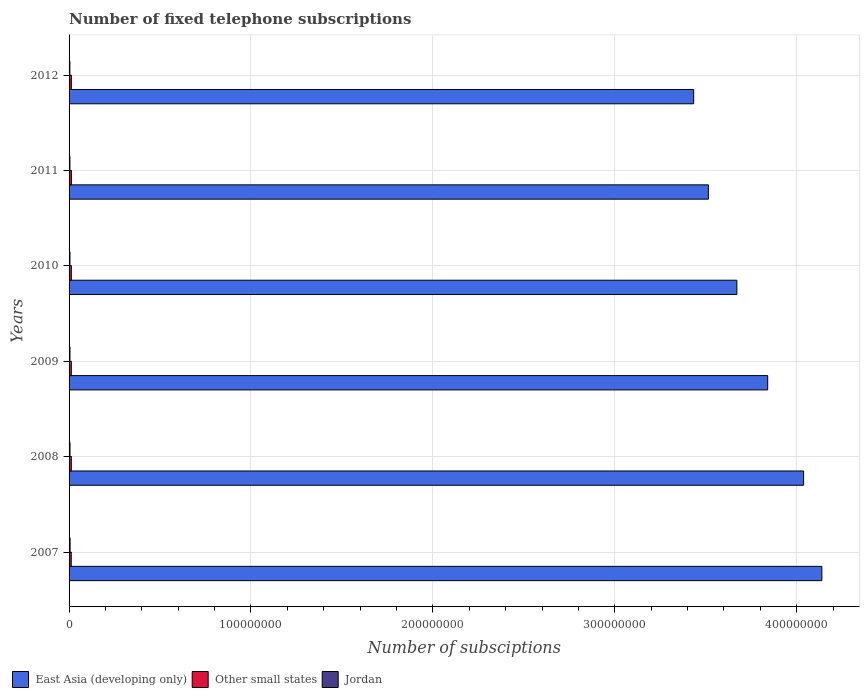How many groups of bars are there?
Provide a succinct answer. 6. Are the number of bars on each tick of the Y-axis equal?
Offer a terse response. Yes. What is the label of the 3rd group of bars from the top?
Keep it short and to the point. 2010. What is the number of fixed telephone subscriptions in Jordan in 2007?
Keep it short and to the point. 5.59e+05. Across all years, what is the maximum number of fixed telephone subscriptions in Other small states?
Provide a short and direct response. 1.27e+06. Across all years, what is the minimum number of fixed telephone subscriptions in East Asia (developing only)?
Your answer should be compact. 3.43e+08. In which year was the number of fixed telephone subscriptions in Jordan maximum?
Make the answer very short. 2007. What is the total number of fixed telephone subscriptions in Jordan in the graph?
Provide a short and direct response. 2.96e+06. What is the difference between the number of fixed telephone subscriptions in Jordan in 2007 and that in 2012?
Offer a terse response. 1.25e+05. What is the difference between the number of fixed telephone subscriptions in Other small states in 2009 and the number of fixed telephone subscriptions in East Asia (developing only) in 2012?
Give a very brief answer. -3.42e+08. What is the average number of fixed telephone subscriptions in Other small states per year?
Your answer should be very brief. 1.24e+06. In the year 2012, what is the difference between the number of fixed telephone subscriptions in Jordan and number of fixed telephone subscriptions in Other small states?
Your answer should be very brief. -8.16e+05. What is the ratio of the number of fixed telephone subscriptions in East Asia (developing only) in 2009 to that in 2010?
Your answer should be compact. 1.05. Is the difference between the number of fixed telephone subscriptions in Jordan in 2007 and 2008 greater than the difference between the number of fixed telephone subscriptions in Other small states in 2007 and 2008?
Offer a terse response. Yes. What is the difference between the highest and the second highest number of fixed telephone subscriptions in Other small states?
Your response must be concise. 1.76e+04. What is the difference between the highest and the lowest number of fixed telephone subscriptions in Other small states?
Offer a very short reply. 6.55e+04. In how many years, is the number of fixed telephone subscriptions in Other small states greater than the average number of fixed telephone subscriptions in Other small states taken over all years?
Provide a succinct answer. 3. Is the sum of the number of fixed telephone subscriptions in Jordan in 2007 and 2011 greater than the maximum number of fixed telephone subscriptions in Other small states across all years?
Provide a succinct answer. No. What does the 2nd bar from the top in 2011 represents?
Give a very brief answer. Other small states. What does the 1st bar from the bottom in 2007 represents?
Your answer should be very brief. East Asia (developing only). Is it the case that in every year, the sum of the number of fixed telephone subscriptions in East Asia (developing only) and number of fixed telephone subscriptions in Jordan is greater than the number of fixed telephone subscriptions in Other small states?
Ensure brevity in your answer.  Yes. Are the values on the major ticks of X-axis written in scientific E-notation?
Your answer should be compact. No. Does the graph contain any zero values?
Keep it short and to the point. No. Does the graph contain grids?
Offer a very short reply. Yes. How are the legend labels stacked?
Ensure brevity in your answer.  Horizontal. What is the title of the graph?
Offer a very short reply. Number of fixed telephone subscriptions. Does "Greenland" appear as one of the legend labels in the graph?
Offer a terse response. No. What is the label or title of the X-axis?
Provide a short and direct response. Number of subsciptions. What is the label or title of the Y-axis?
Provide a succinct answer. Years. What is the Number of subsciptions in East Asia (developing only) in 2007?
Ensure brevity in your answer.  4.14e+08. What is the Number of subsciptions of Other small states in 2007?
Provide a short and direct response. 1.20e+06. What is the Number of subsciptions of Jordan in 2007?
Offer a terse response. 5.59e+05. What is the Number of subsciptions in East Asia (developing only) in 2008?
Give a very brief answer. 4.04e+08. What is the Number of subsciptions in Other small states in 2008?
Ensure brevity in your answer.  1.23e+06. What is the Number of subsciptions of Jordan in 2008?
Your answer should be compact. 5.19e+05. What is the Number of subsciptions of East Asia (developing only) in 2009?
Ensure brevity in your answer.  3.84e+08. What is the Number of subsciptions of Other small states in 2009?
Ensure brevity in your answer.  1.23e+06. What is the Number of subsciptions in Jordan in 2009?
Give a very brief answer. 5.01e+05. What is the Number of subsciptions of East Asia (developing only) in 2010?
Your answer should be very brief. 3.67e+08. What is the Number of subsciptions of Other small states in 2010?
Make the answer very short. 1.24e+06. What is the Number of subsciptions of Jordan in 2010?
Offer a very short reply. 4.86e+05. What is the Number of subsciptions of East Asia (developing only) in 2011?
Your answer should be very brief. 3.52e+08. What is the Number of subsciptions of Other small states in 2011?
Your response must be concise. 1.27e+06. What is the Number of subsciptions in Jordan in 2011?
Your answer should be compact. 4.65e+05. What is the Number of subsciptions of East Asia (developing only) in 2012?
Provide a short and direct response. 3.43e+08. What is the Number of subsciptions in Other small states in 2012?
Your answer should be very brief. 1.25e+06. What is the Number of subsciptions of Jordan in 2012?
Make the answer very short. 4.34e+05. Across all years, what is the maximum Number of subsciptions in East Asia (developing only)?
Make the answer very short. 4.14e+08. Across all years, what is the maximum Number of subsciptions in Other small states?
Your response must be concise. 1.27e+06. Across all years, what is the maximum Number of subsciptions of Jordan?
Provide a succinct answer. 5.59e+05. Across all years, what is the minimum Number of subsciptions in East Asia (developing only)?
Your answer should be very brief. 3.43e+08. Across all years, what is the minimum Number of subsciptions in Other small states?
Keep it short and to the point. 1.20e+06. Across all years, what is the minimum Number of subsciptions in Jordan?
Make the answer very short. 4.34e+05. What is the total Number of subsciptions of East Asia (developing only) in the graph?
Give a very brief answer. 2.26e+09. What is the total Number of subsciptions in Other small states in the graph?
Your answer should be compact. 7.42e+06. What is the total Number of subsciptions in Jordan in the graph?
Your response must be concise. 2.96e+06. What is the difference between the Number of subsciptions in East Asia (developing only) in 2007 and that in 2008?
Your response must be concise. 1.00e+07. What is the difference between the Number of subsciptions of Other small states in 2007 and that in 2008?
Make the answer very short. -2.89e+04. What is the difference between the Number of subsciptions of Jordan in 2007 and that in 2008?
Offer a very short reply. 4.00e+04. What is the difference between the Number of subsciptions of East Asia (developing only) in 2007 and that in 2009?
Your answer should be compact. 2.98e+07. What is the difference between the Number of subsciptions of Other small states in 2007 and that in 2009?
Your answer should be very brief. -2.89e+04. What is the difference between the Number of subsciptions in Jordan in 2007 and that in 2009?
Provide a succinct answer. 5.78e+04. What is the difference between the Number of subsciptions in East Asia (developing only) in 2007 and that in 2010?
Offer a very short reply. 4.67e+07. What is the difference between the Number of subsciptions of Other small states in 2007 and that in 2010?
Keep it short and to the point. -3.91e+04. What is the difference between the Number of subsciptions in Jordan in 2007 and that in 2010?
Provide a short and direct response. 7.35e+04. What is the difference between the Number of subsciptions in East Asia (developing only) in 2007 and that in 2011?
Your answer should be compact. 6.24e+07. What is the difference between the Number of subsciptions in Other small states in 2007 and that in 2011?
Your response must be concise. -6.55e+04. What is the difference between the Number of subsciptions in Jordan in 2007 and that in 2011?
Provide a succinct answer. 9.36e+04. What is the difference between the Number of subsciptions of East Asia (developing only) in 2007 and that in 2012?
Provide a short and direct response. 7.05e+07. What is the difference between the Number of subsciptions of Other small states in 2007 and that in 2012?
Give a very brief answer. -4.79e+04. What is the difference between the Number of subsciptions of Jordan in 2007 and that in 2012?
Provide a succinct answer. 1.25e+05. What is the difference between the Number of subsciptions in East Asia (developing only) in 2008 and that in 2009?
Offer a very short reply. 1.97e+07. What is the difference between the Number of subsciptions in Other small states in 2008 and that in 2009?
Your response must be concise. -35. What is the difference between the Number of subsciptions of Jordan in 2008 and that in 2009?
Your answer should be very brief. 1.78e+04. What is the difference between the Number of subsciptions of East Asia (developing only) in 2008 and that in 2010?
Make the answer very short. 3.67e+07. What is the difference between the Number of subsciptions in Other small states in 2008 and that in 2010?
Provide a succinct answer. -1.02e+04. What is the difference between the Number of subsciptions in Jordan in 2008 and that in 2010?
Your answer should be compact. 3.35e+04. What is the difference between the Number of subsciptions of East Asia (developing only) in 2008 and that in 2011?
Your response must be concise. 5.23e+07. What is the difference between the Number of subsciptions of Other small states in 2008 and that in 2011?
Your response must be concise. -3.67e+04. What is the difference between the Number of subsciptions in Jordan in 2008 and that in 2011?
Make the answer very short. 5.36e+04. What is the difference between the Number of subsciptions in East Asia (developing only) in 2008 and that in 2012?
Offer a very short reply. 6.04e+07. What is the difference between the Number of subsciptions of Other small states in 2008 and that in 2012?
Your answer should be very brief. -1.90e+04. What is the difference between the Number of subsciptions in Jordan in 2008 and that in 2012?
Ensure brevity in your answer.  8.46e+04. What is the difference between the Number of subsciptions in East Asia (developing only) in 2009 and that in 2010?
Provide a short and direct response. 1.69e+07. What is the difference between the Number of subsciptions of Other small states in 2009 and that in 2010?
Make the answer very short. -1.02e+04. What is the difference between the Number of subsciptions in Jordan in 2009 and that in 2010?
Keep it short and to the point. 1.57e+04. What is the difference between the Number of subsciptions in East Asia (developing only) in 2009 and that in 2011?
Your answer should be compact. 3.26e+07. What is the difference between the Number of subsciptions of Other small states in 2009 and that in 2011?
Provide a short and direct response. -3.66e+04. What is the difference between the Number of subsciptions in Jordan in 2009 and that in 2011?
Give a very brief answer. 3.58e+04. What is the difference between the Number of subsciptions of East Asia (developing only) in 2009 and that in 2012?
Make the answer very short. 4.07e+07. What is the difference between the Number of subsciptions in Other small states in 2009 and that in 2012?
Offer a very short reply. -1.90e+04. What is the difference between the Number of subsciptions in Jordan in 2009 and that in 2012?
Your response must be concise. 6.68e+04. What is the difference between the Number of subsciptions in East Asia (developing only) in 2010 and that in 2011?
Make the answer very short. 1.56e+07. What is the difference between the Number of subsciptions in Other small states in 2010 and that in 2011?
Offer a terse response. -2.65e+04. What is the difference between the Number of subsciptions of Jordan in 2010 and that in 2011?
Ensure brevity in your answer.  2.01e+04. What is the difference between the Number of subsciptions in East Asia (developing only) in 2010 and that in 2012?
Make the answer very short. 2.38e+07. What is the difference between the Number of subsciptions in Other small states in 2010 and that in 2012?
Give a very brief answer. -8862. What is the difference between the Number of subsciptions in Jordan in 2010 and that in 2012?
Give a very brief answer. 5.11e+04. What is the difference between the Number of subsciptions of East Asia (developing only) in 2011 and that in 2012?
Make the answer very short. 8.12e+06. What is the difference between the Number of subsciptions of Other small states in 2011 and that in 2012?
Offer a terse response. 1.76e+04. What is the difference between the Number of subsciptions of Jordan in 2011 and that in 2012?
Your answer should be very brief. 3.10e+04. What is the difference between the Number of subsciptions in East Asia (developing only) in 2007 and the Number of subsciptions in Other small states in 2008?
Offer a very short reply. 4.13e+08. What is the difference between the Number of subsciptions in East Asia (developing only) in 2007 and the Number of subsciptions in Jordan in 2008?
Your answer should be very brief. 4.13e+08. What is the difference between the Number of subsciptions in Other small states in 2007 and the Number of subsciptions in Jordan in 2008?
Make the answer very short. 6.83e+05. What is the difference between the Number of subsciptions in East Asia (developing only) in 2007 and the Number of subsciptions in Other small states in 2009?
Give a very brief answer. 4.13e+08. What is the difference between the Number of subsciptions in East Asia (developing only) in 2007 and the Number of subsciptions in Jordan in 2009?
Make the answer very short. 4.13e+08. What is the difference between the Number of subsciptions of Other small states in 2007 and the Number of subsciptions of Jordan in 2009?
Your answer should be very brief. 7.01e+05. What is the difference between the Number of subsciptions of East Asia (developing only) in 2007 and the Number of subsciptions of Other small states in 2010?
Offer a terse response. 4.13e+08. What is the difference between the Number of subsciptions in East Asia (developing only) in 2007 and the Number of subsciptions in Jordan in 2010?
Your response must be concise. 4.13e+08. What is the difference between the Number of subsciptions in Other small states in 2007 and the Number of subsciptions in Jordan in 2010?
Make the answer very short. 7.16e+05. What is the difference between the Number of subsciptions of East Asia (developing only) in 2007 and the Number of subsciptions of Other small states in 2011?
Your answer should be very brief. 4.13e+08. What is the difference between the Number of subsciptions of East Asia (developing only) in 2007 and the Number of subsciptions of Jordan in 2011?
Provide a short and direct response. 4.13e+08. What is the difference between the Number of subsciptions of Other small states in 2007 and the Number of subsciptions of Jordan in 2011?
Offer a terse response. 7.37e+05. What is the difference between the Number of subsciptions in East Asia (developing only) in 2007 and the Number of subsciptions in Other small states in 2012?
Give a very brief answer. 4.13e+08. What is the difference between the Number of subsciptions in East Asia (developing only) in 2007 and the Number of subsciptions in Jordan in 2012?
Offer a terse response. 4.13e+08. What is the difference between the Number of subsciptions of Other small states in 2007 and the Number of subsciptions of Jordan in 2012?
Provide a short and direct response. 7.68e+05. What is the difference between the Number of subsciptions in East Asia (developing only) in 2008 and the Number of subsciptions in Other small states in 2009?
Offer a terse response. 4.03e+08. What is the difference between the Number of subsciptions in East Asia (developing only) in 2008 and the Number of subsciptions in Jordan in 2009?
Your answer should be compact. 4.03e+08. What is the difference between the Number of subsciptions of Other small states in 2008 and the Number of subsciptions of Jordan in 2009?
Your answer should be very brief. 7.30e+05. What is the difference between the Number of subsciptions of East Asia (developing only) in 2008 and the Number of subsciptions of Other small states in 2010?
Give a very brief answer. 4.03e+08. What is the difference between the Number of subsciptions of East Asia (developing only) in 2008 and the Number of subsciptions of Jordan in 2010?
Offer a terse response. 4.03e+08. What is the difference between the Number of subsciptions in Other small states in 2008 and the Number of subsciptions in Jordan in 2010?
Your answer should be very brief. 7.45e+05. What is the difference between the Number of subsciptions in East Asia (developing only) in 2008 and the Number of subsciptions in Other small states in 2011?
Give a very brief answer. 4.03e+08. What is the difference between the Number of subsciptions in East Asia (developing only) in 2008 and the Number of subsciptions in Jordan in 2011?
Ensure brevity in your answer.  4.03e+08. What is the difference between the Number of subsciptions in Other small states in 2008 and the Number of subsciptions in Jordan in 2011?
Your response must be concise. 7.66e+05. What is the difference between the Number of subsciptions in East Asia (developing only) in 2008 and the Number of subsciptions in Other small states in 2012?
Your answer should be very brief. 4.03e+08. What is the difference between the Number of subsciptions in East Asia (developing only) in 2008 and the Number of subsciptions in Jordan in 2012?
Provide a short and direct response. 4.03e+08. What is the difference between the Number of subsciptions of Other small states in 2008 and the Number of subsciptions of Jordan in 2012?
Your answer should be very brief. 7.96e+05. What is the difference between the Number of subsciptions of East Asia (developing only) in 2009 and the Number of subsciptions of Other small states in 2010?
Your response must be concise. 3.83e+08. What is the difference between the Number of subsciptions of East Asia (developing only) in 2009 and the Number of subsciptions of Jordan in 2010?
Offer a very short reply. 3.84e+08. What is the difference between the Number of subsciptions of Other small states in 2009 and the Number of subsciptions of Jordan in 2010?
Your response must be concise. 7.45e+05. What is the difference between the Number of subsciptions in East Asia (developing only) in 2009 and the Number of subsciptions in Other small states in 2011?
Provide a succinct answer. 3.83e+08. What is the difference between the Number of subsciptions of East Asia (developing only) in 2009 and the Number of subsciptions of Jordan in 2011?
Give a very brief answer. 3.84e+08. What is the difference between the Number of subsciptions of Other small states in 2009 and the Number of subsciptions of Jordan in 2011?
Offer a terse response. 7.66e+05. What is the difference between the Number of subsciptions of East Asia (developing only) in 2009 and the Number of subsciptions of Other small states in 2012?
Keep it short and to the point. 3.83e+08. What is the difference between the Number of subsciptions in East Asia (developing only) in 2009 and the Number of subsciptions in Jordan in 2012?
Your answer should be very brief. 3.84e+08. What is the difference between the Number of subsciptions in Other small states in 2009 and the Number of subsciptions in Jordan in 2012?
Your answer should be compact. 7.97e+05. What is the difference between the Number of subsciptions in East Asia (developing only) in 2010 and the Number of subsciptions in Other small states in 2011?
Give a very brief answer. 3.66e+08. What is the difference between the Number of subsciptions in East Asia (developing only) in 2010 and the Number of subsciptions in Jordan in 2011?
Offer a terse response. 3.67e+08. What is the difference between the Number of subsciptions of Other small states in 2010 and the Number of subsciptions of Jordan in 2011?
Provide a succinct answer. 7.76e+05. What is the difference between the Number of subsciptions of East Asia (developing only) in 2010 and the Number of subsciptions of Other small states in 2012?
Your answer should be compact. 3.66e+08. What is the difference between the Number of subsciptions of East Asia (developing only) in 2010 and the Number of subsciptions of Jordan in 2012?
Make the answer very short. 3.67e+08. What is the difference between the Number of subsciptions of Other small states in 2010 and the Number of subsciptions of Jordan in 2012?
Offer a terse response. 8.07e+05. What is the difference between the Number of subsciptions in East Asia (developing only) in 2011 and the Number of subsciptions in Other small states in 2012?
Offer a very short reply. 3.50e+08. What is the difference between the Number of subsciptions in East Asia (developing only) in 2011 and the Number of subsciptions in Jordan in 2012?
Your answer should be very brief. 3.51e+08. What is the difference between the Number of subsciptions of Other small states in 2011 and the Number of subsciptions of Jordan in 2012?
Make the answer very short. 8.33e+05. What is the average Number of subsciptions in East Asia (developing only) per year?
Offer a terse response. 3.77e+08. What is the average Number of subsciptions of Other small states per year?
Offer a terse response. 1.24e+06. What is the average Number of subsciptions in Jordan per year?
Your answer should be compact. 4.94e+05. In the year 2007, what is the difference between the Number of subsciptions in East Asia (developing only) and Number of subsciptions in Other small states?
Provide a short and direct response. 4.13e+08. In the year 2007, what is the difference between the Number of subsciptions of East Asia (developing only) and Number of subsciptions of Jordan?
Give a very brief answer. 4.13e+08. In the year 2007, what is the difference between the Number of subsciptions in Other small states and Number of subsciptions in Jordan?
Ensure brevity in your answer.  6.43e+05. In the year 2008, what is the difference between the Number of subsciptions in East Asia (developing only) and Number of subsciptions in Other small states?
Your answer should be very brief. 4.03e+08. In the year 2008, what is the difference between the Number of subsciptions of East Asia (developing only) and Number of subsciptions of Jordan?
Keep it short and to the point. 4.03e+08. In the year 2008, what is the difference between the Number of subsciptions in Other small states and Number of subsciptions in Jordan?
Offer a very short reply. 7.12e+05. In the year 2009, what is the difference between the Number of subsciptions in East Asia (developing only) and Number of subsciptions in Other small states?
Offer a terse response. 3.83e+08. In the year 2009, what is the difference between the Number of subsciptions of East Asia (developing only) and Number of subsciptions of Jordan?
Keep it short and to the point. 3.84e+08. In the year 2009, what is the difference between the Number of subsciptions of Other small states and Number of subsciptions of Jordan?
Offer a very short reply. 7.30e+05. In the year 2010, what is the difference between the Number of subsciptions in East Asia (developing only) and Number of subsciptions in Other small states?
Your response must be concise. 3.66e+08. In the year 2010, what is the difference between the Number of subsciptions of East Asia (developing only) and Number of subsciptions of Jordan?
Make the answer very short. 3.67e+08. In the year 2010, what is the difference between the Number of subsciptions of Other small states and Number of subsciptions of Jordan?
Ensure brevity in your answer.  7.56e+05. In the year 2011, what is the difference between the Number of subsciptions in East Asia (developing only) and Number of subsciptions in Other small states?
Offer a terse response. 3.50e+08. In the year 2011, what is the difference between the Number of subsciptions of East Asia (developing only) and Number of subsciptions of Jordan?
Your answer should be very brief. 3.51e+08. In the year 2011, what is the difference between the Number of subsciptions of Other small states and Number of subsciptions of Jordan?
Ensure brevity in your answer.  8.02e+05. In the year 2012, what is the difference between the Number of subsciptions of East Asia (developing only) and Number of subsciptions of Other small states?
Your response must be concise. 3.42e+08. In the year 2012, what is the difference between the Number of subsciptions in East Asia (developing only) and Number of subsciptions in Jordan?
Make the answer very short. 3.43e+08. In the year 2012, what is the difference between the Number of subsciptions of Other small states and Number of subsciptions of Jordan?
Ensure brevity in your answer.  8.16e+05. What is the ratio of the Number of subsciptions in East Asia (developing only) in 2007 to that in 2008?
Your response must be concise. 1.02. What is the ratio of the Number of subsciptions of Other small states in 2007 to that in 2008?
Give a very brief answer. 0.98. What is the ratio of the Number of subsciptions of Jordan in 2007 to that in 2008?
Provide a short and direct response. 1.08. What is the ratio of the Number of subsciptions in East Asia (developing only) in 2007 to that in 2009?
Your response must be concise. 1.08. What is the ratio of the Number of subsciptions of Other small states in 2007 to that in 2009?
Your answer should be very brief. 0.98. What is the ratio of the Number of subsciptions in Jordan in 2007 to that in 2009?
Give a very brief answer. 1.12. What is the ratio of the Number of subsciptions in East Asia (developing only) in 2007 to that in 2010?
Ensure brevity in your answer.  1.13. What is the ratio of the Number of subsciptions in Other small states in 2007 to that in 2010?
Keep it short and to the point. 0.97. What is the ratio of the Number of subsciptions of Jordan in 2007 to that in 2010?
Keep it short and to the point. 1.15. What is the ratio of the Number of subsciptions of East Asia (developing only) in 2007 to that in 2011?
Your answer should be compact. 1.18. What is the ratio of the Number of subsciptions in Other small states in 2007 to that in 2011?
Provide a succinct answer. 0.95. What is the ratio of the Number of subsciptions in Jordan in 2007 to that in 2011?
Offer a very short reply. 1.2. What is the ratio of the Number of subsciptions in East Asia (developing only) in 2007 to that in 2012?
Offer a very short reply. 1.21. What is the ratio of the Number of subsciptions in Other small states in 2007 to that in 2012?
Give a very brief answer. 0.96. What is the ratio of the Number of subsciptions of Jordan in 2007 to that in 2012?
Provide a succinct answer. 1.29. What is the ratio of the Number of subsciptions of East Asia (developing only) in 2008 to that in 2009?
Your answer should be compact. 1.05. What is the ratio of the Number of subsciptions in Other small states in 2008 to that in 2009?
Provide a succinct answer. 1. What is the ratio of the Number of subsciptions of Jordan in 2008 to that in 2009?
Your answer should be compact. 1.04. What is the ratio of the Number of subsciptions in East Asia (developing only) in 2008 to that in 2010?
Your answer should be very brief. 1.1. What is the ratio of the Number of subsciptions in Jordan in 2008 to that in 2010?
Keep it short and to the point. 1.07. What is the ratio of the Number of subsciptions in East Asia (developing only) in 2008 to that in 2011?
Keep it short and to the point. 1.15. What is the ratio of the Number of subsciptions of Other small states in 2008 to that in 2011?
Offer a terse response. 0.97. What is the ratio of the Number of subsciptions in Jordan in 2008 to that in 2011?
Your response must be concise. 1.12. What is the ratio of the Number of subsciptions in East Asia (developing only) in 2008 to that in 2012?
Keep it short and to the point. 1.18. What is the ratio of the Number of subsciptions in Jordan in 2008 to that in 2012?
Your answer should be very brief. 1.19. What is the ratio of the Number of subsciptions of East Asia (developing only) in 2009 to that in 2010?
Keep it short and to the point. 1.05. What is the ratio of the Number of subsciptions of Other small states in 2009 to that in 2010?
Your response must be concise. 0.99. What is the ratio of the Number of subsciptions in Jordan in 2009 to that in 2010?
Your response must be concise. 1.03. What is the ratio of the Number of subsciptions in East Asia (developing only) in 2009 to that in 2011?
Ensure brevity in your answer.  1.09. What is the ratio of the Number of subsciptions in Other small states in 2009 to that in 2011?
Provide a succinct answer. 0.97. What is the ratio of the Number of subsciptions in Jordan in 2009 to that in 2011?
Offer a very short reply. 1.08. What is the ratio of the Number of subsciptions of East Asia (developing only) in 2009 to that in 2012?
Your response must be concise. 1.12. What is the ratio of the Number of subsciptions in Jordan in 2009 to that in 2012?
Give a very brief answer. 1.15. What is the ratio of the Number of subsciptions in East Asia (developing only) in 2010 to that in 2011?
Provide a succinct answer. 1.04. What is the ratio of the Number of subsciptions of Other small states in 2010 to that in 2011?
Your answer should be very brief. 0.98. What is the ratio of the Number of subsciptions of Jordan in 2010 to that in 2011?
Your answer should be very brief. 1.04. What is the ratio of the Number of subsciptions in East Asia (developing only) in 2010 to that in 2012?
Your response must be concise. 1.07. What is the ratio of the Number of subsciptions in Jordan in 2010 to that in 2012?
Offer a terse response. 1.12. What is the ratio of the Number of subsciptions of East Asia (developing only) in 2011 to that in 2012?
Offer a very short reply. 1.02. What is the ratio of the Number of subsciptions in Other small states in 2011 to that in 2012?
Keep it short and to the point. 1.01. What is the ratio of the Number of subsciptions of Jordan in 2011 to that in 2012?
Offer a very short reply. 1.07. What is the difference between the highest and the second highest Number of subsciptions of East Asia (developing only)?
Make the answer very short. 1.00e+07. What is the difference between the highest and the second highest Number of subsciptions of Other small states?
Give a very brief answer. 1.76e+04. What is the difference between the highest and the second highest Number of subsciptions in Jordan?
Make the answer very short. 4.00e+04. What is the difference between the highest and the lowest Number of subsciptions of East Asia (developing only)?
Keep it short and to the point. 7.05e+07. What is the difference between the highest and the lowest Number of subsciptions of Other small states?
Offer a very short reply. 6.55e+04. What is the difference between the highest and the lowest Number of subsciptions of Jordan?
Ensure brevity in your answer.  1.25e+05. 